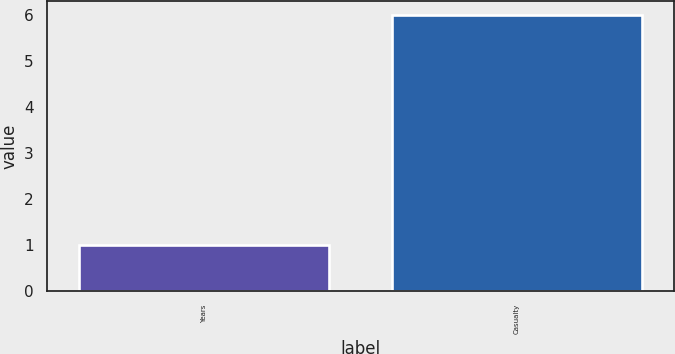Convert chart. <chart><loc_0><loc_0><loc_500><loc_500><bar_chart><fcel>Years<fcel>Casualty<nl><fcel>1<fcel>6<nl></chart> 